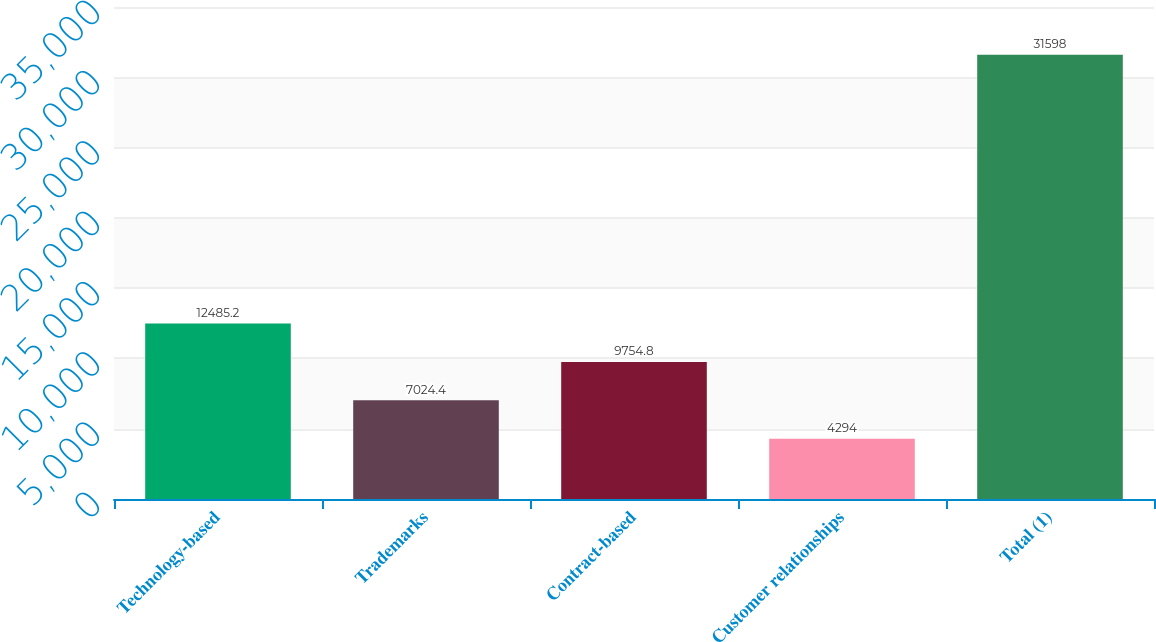<chart> <loc_0><loc_0><loc_500><loc_500><bar_chart><fcel>Technology-based<fcel>Trademarks<fcel>Contract-based<fcel>Customer relationships<fcel>Total (1)<nl><fcel>12485.2<fcel>7024.4<fcel>9754.8<fcel>4294<fcel>31598<nl></chart> 